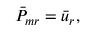Convert formula to latex. <formula><loc_0><loc_0><loc_500><loc_500>\bar { P } _ { m r } = \bar { u } _ { r } ,</formula> 